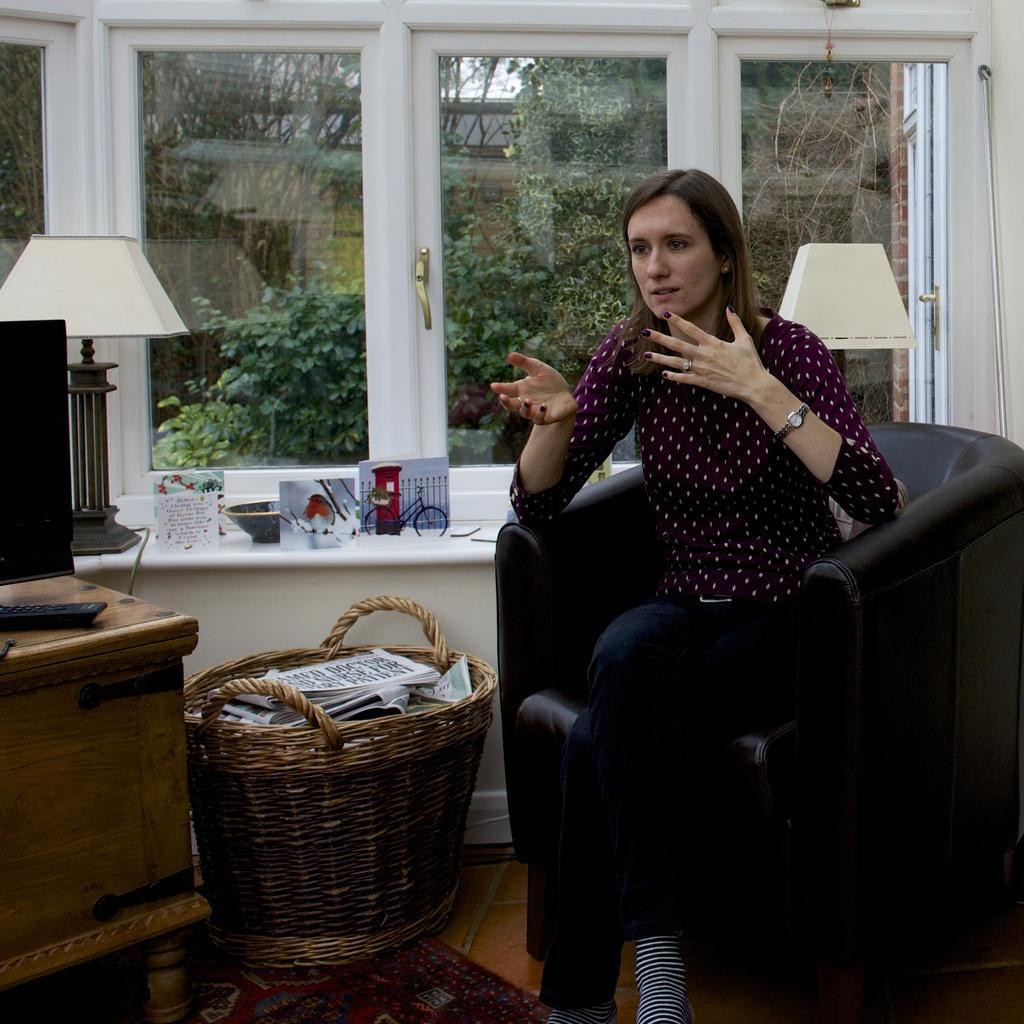How would you summarize this image in a sentence or two? In this image i can see a inside view of house. on the right side there is sofa set ,on the sofa set a woman sit ,and she is wearing a red color jacket and her mouth was open. And back side of her there is a window. And back side of window there are some trees. And left side there is a lamp,on the left side there is a table. on the middle there is bucket of wooden. And there i s papers and bowls kept on the floor. 